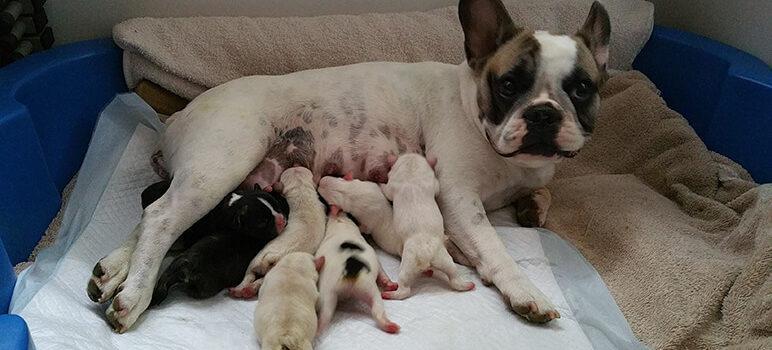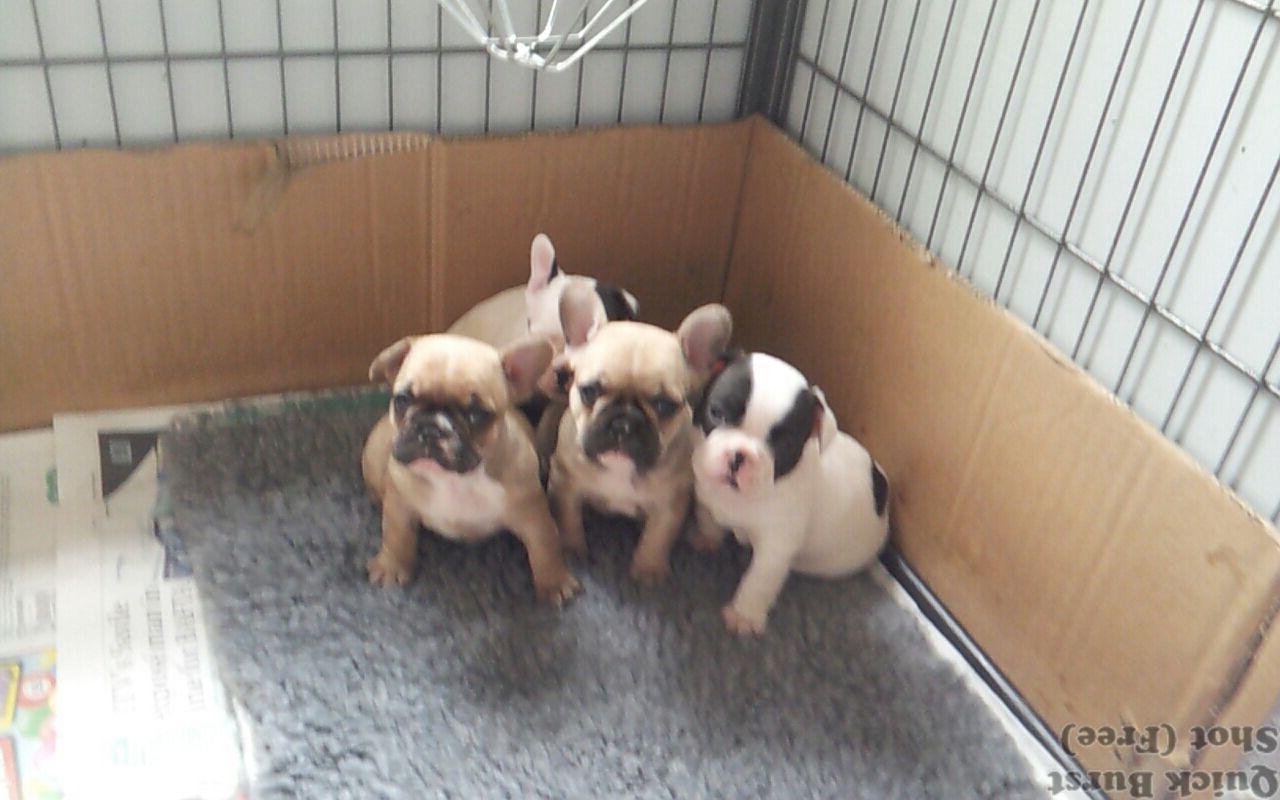The first image is the image on the left, the second image is the image on the right. Assess this claim about the two images: "There are no more than five dogs in the right image.". Correct or not? Answer yes or no. Yes. 